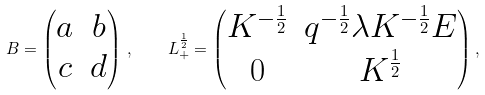<formula> <loc_0><loc_0><loc_500><loc_500>B = \begin{pmatrix} a & b \\ c & d \end{pmatrix} \, , \quad L _ { + } ^ { \frac { 1 } { 2 } } = \begin{pmatrix} K ^ { - \frac { 1 } { 2 } } & q ^ { - \frac { 1 } { 2 } } \lambda K ^ { - \frac { 1 } { 2 } } E \\ 0 & K ^ { \frac { 1 } { 2 } } \end{pmatrix} ,</formula> 